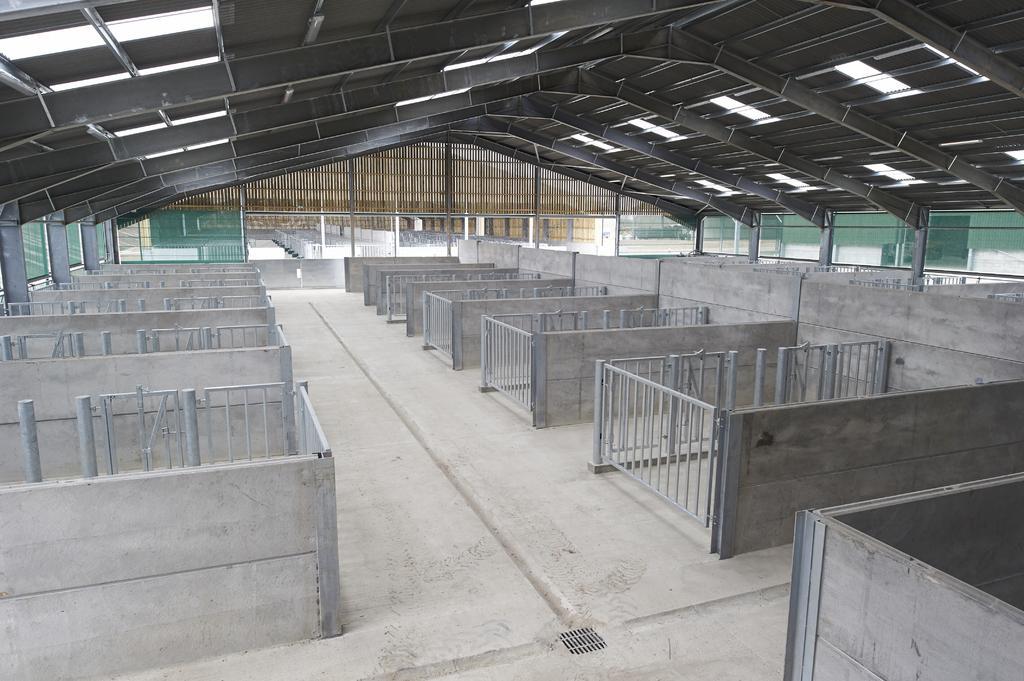How would you summarize this image in a sentence or two? In this image I can see the ground, the railing and few walls. I can see the ceiling and in the background I can see another building. 